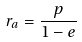Convert formula to latex. <formula><loc_0><loc_0><loc_500><loc_500>r _ { a } = \frac { p } { 1 - e }</formula> 